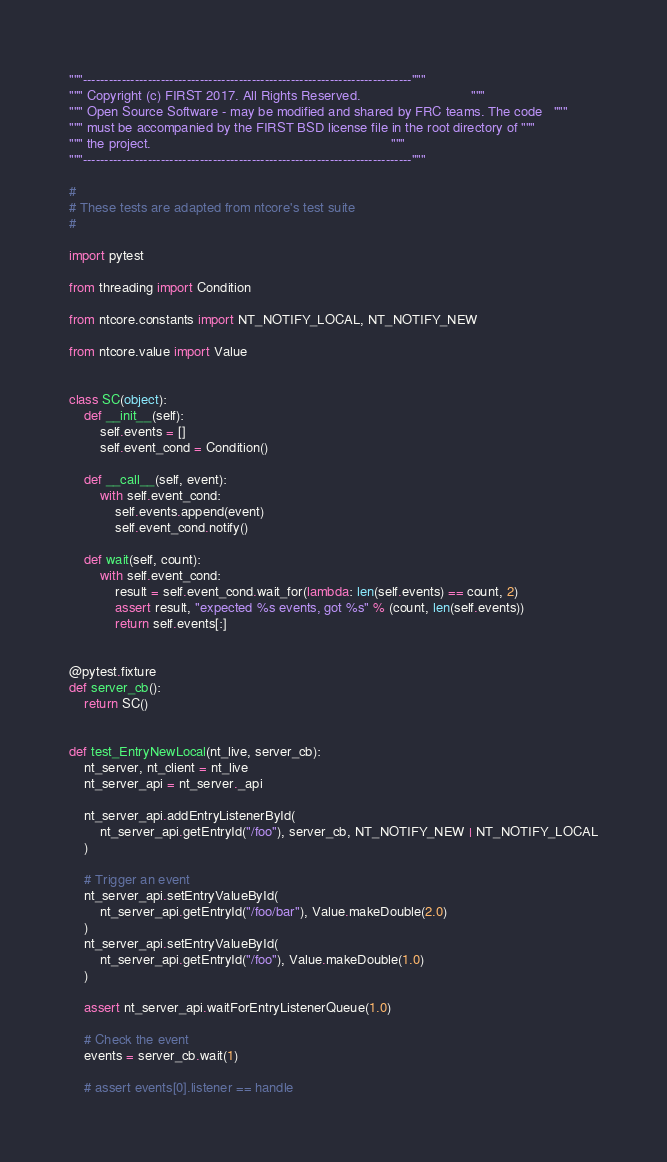Convert code to text. <code><loc_0><loc_0><loc_500><loc_500><_Python_>"""----------------------------------------------------------------------------"""
""" Copyright (c) FIRST 2017. All Rights Reserved.                             """
""" Open Source Software - may be modified and shared by FRC teams. The code   """
""" must be accompanied by the FIRST BSD license file in the root directory of """
""" the project.                                                               """
"""----------------------------------------------------------------------------"""

#
# These tests are adapted from ntcore's test suite
#

import pytest

from threading import Condition

from ntcore.constants import NT_NOTIFY_LOCAL, NT_NOTIFY_NEW

from ntcore.value import Value


class SC(object):
    def __init__(self):
        self.events = []
        self.event_cond = Condition()

    def __call__(self, event):
        with self.event_cond:
            self.events.append(event)
            self.event_cond.notify()

    def wait(self, count):
        with self.event_cond:
            result = self.event_cond.wait_for(lambda: len(self.events) == count, 2)
            assert result, "expected %s events, got %s" % (count, len(self.events))
            return self.events[:]


@pytest.fixture
def server_cb():
    return SC()


def test_EntryNewLocal(nt_live, server_cb):
    nt_server, nt_client = nt_live
    nt_server_api = nt_server._api

    nt_server_api.addEntryListenerById(
        nt_server_api.getEntryId("/foo"), server_cb, NT_NOTIFY_NEW | NT_NOTIFY_LOCAL
    )

    # Trigger an event
    nt_server_api.setEntryValueById(
        nt_server_api.getEntryId("/foo/bar"), Value.makeDouble(2.0)
    )
    nt_server_api.setEntryValueById(
        nt_server_api.getEntryId("/foo"), Value.makeDouble(1.0)
    )

    assert nt_server_api.waitForEntryListenerQueue(1.0)

    # Check the event
    events = server_cb.wait(1)

    # assert events[0].listener == handle</code> 